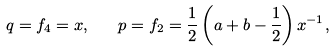<formula> <loc_0><loc_0><loc_500><loc_500>q = f _ { 4 } = x , \quad p = f _ { 2 } = \frac { 1 } { 2 } \left ( a + b - \frac { 1 } { 2 } \right ) x ^ { - 1 } ,</formula> 